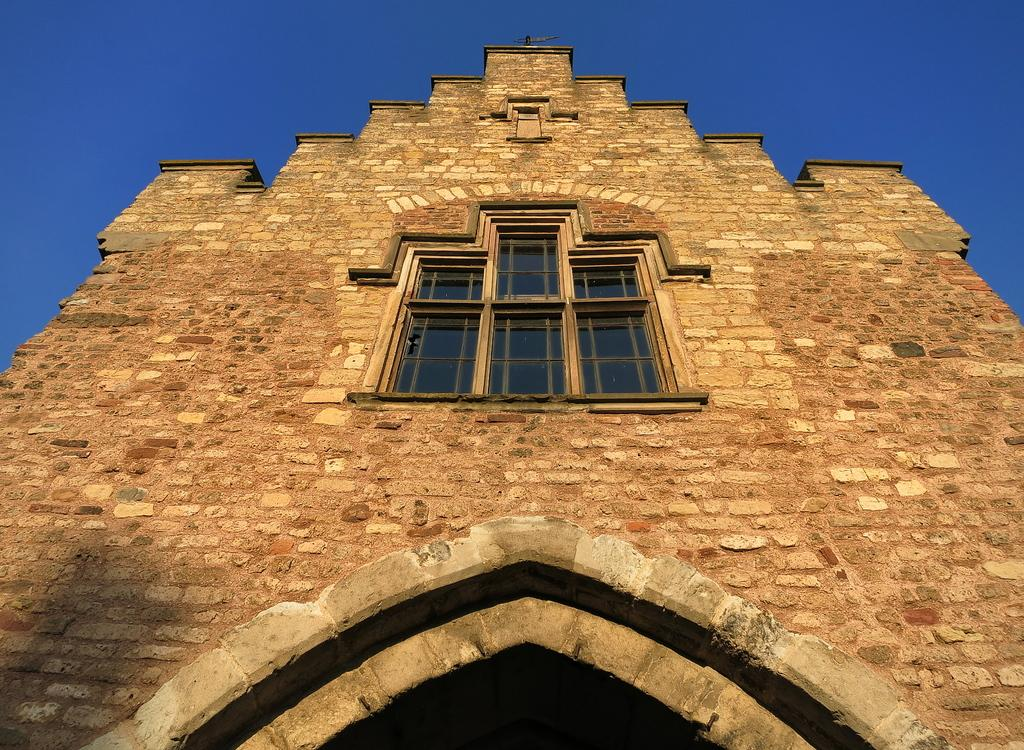What structure is present in the image? There is a building in the image. What feature can be seen on the building? The building has a window in the middle. What is visible above the building? The sky is visible above the building. What type of teeth can be seen in the image? There are no teeth present in the image. What substance is being used to construct the building in the image? The facts provided do not give information about the materials used to construct the building. 